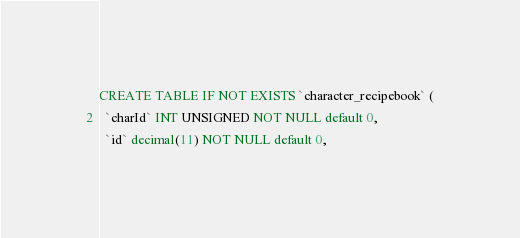Convert code to text. <code><loc_0><loc_0><loc_500><loc_500><_SQL_>CREATE TABLE IF NOT EXISTS `character_recipebook` (
  `charId` INT UNSIGNED NOT NULL default 0,
  `id` decimal(11) NOT NULL default 0,</code> 